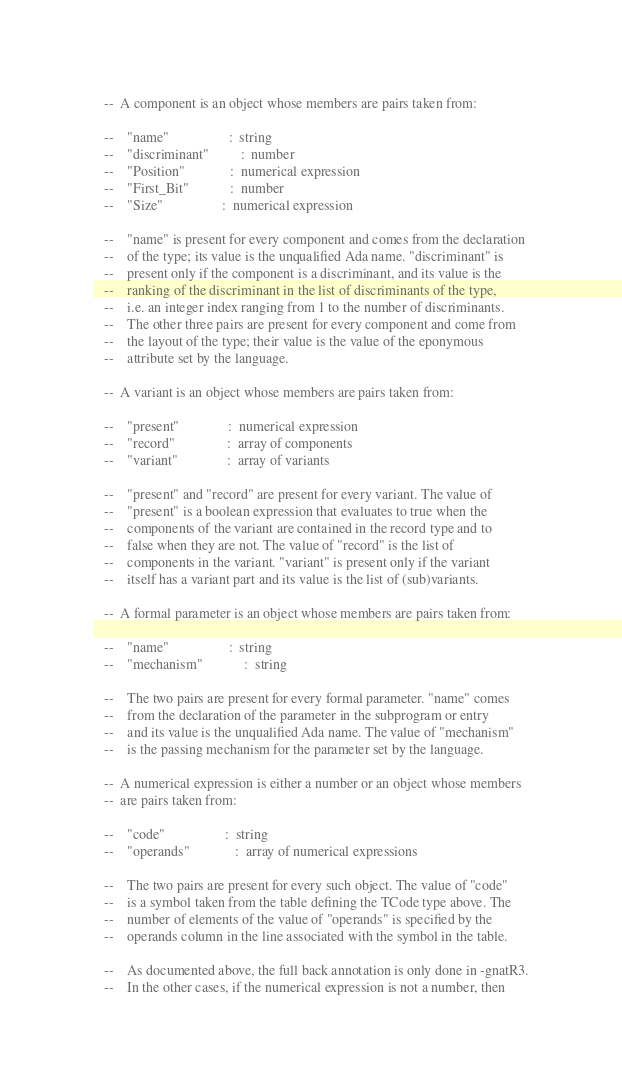Convert code to text. <code><loc_0><loc_0><loc_500><loc_500><_Ada_>
   --  A component is an object whose members are pairs taken from:

   --    "name"                 :  string
   --    "discriminant"         :  number
   --    "Position"             :  numerical expression
   --    "First_Bit"            :  number
   --    "Size"                 :  numerical expression

   --    "name" is present for every component and comes from the declaration
   --    of the type; its value is the unqualified Ada name. "discriminant" is
   --    present only if the component is a discriminant, and its value is the
   --    ranking of the discriminant in the list of discriminants of the type,
   --    i.e. an integer index ranging from 1 to the number of discriminants.
   --    The other three pairs are present for every component and come from
   --    the layout of the type; their value is the value of the eponymous
   --    attribute set by the language.

   --  A variant is an object whose members are pairs taken from:

   --    "present"              :  numerical expression
   --    "record"               :  array of components
   --    "variant"              :  array of variants

   --    "present" and "record" are present for every variant. The value of
   --    "present" is a boolean expression that evaluates to true when the
   --    components of the variant are contained in the record type and to
   --    false when they are not. The value of "record" is the list of
   --    components in the variant. "variant" is present only if the variant
   --    itself has a variant part and its value is the list of (sub)variants.

   --  A formal parameter is an object whose members are pairs taken from:

   --    "name"                 :  string
   --    "mechanism"            :  string

   --    The two pairs are present for every formal parameter. "name" comes
   --    from the declaration of the parameter in the subprogram or entry
   --    and its value is the unqualified Ada name. The value of "mechanism"
   --    is the passing mechanism for the parameter set by the language.

   --  A numerical expression is either a number or an object whose members
   --  are pairs taken from:

   --    "code"                 :  string
   --    "operands"             :  array of numerical expressions

   --    The two pairs are present for every such object. The value of "code"
   --    is a symbol taken from the table defining the TCode type above. The
   --    number of elements of the value of "operands" is specified by the
   --    operands column in the line associated with the symbol in the table.

   --    As documented above, the full back annotation is only done in -gnatR3.
   --    In the other cases, if the numerical expression is not a number, then</code> 